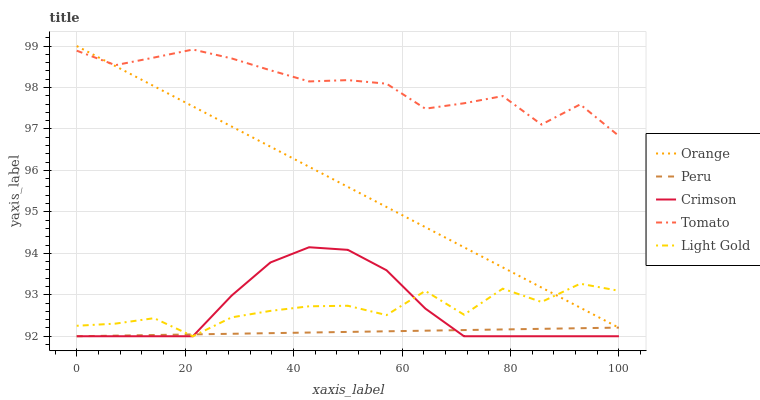Does Peru have the minimum area under the curve?
Answer yes or no. Yes. Does Tomato have the maximum area under the curve?
Answer yes or no. Yes. Does Crimson have the minimum area under the curve?
Answer yes or no. No. Does Crimson have the maximum area under the curve?
Answer yes or no. No. Is Peru the smoothest?
Answer yes or no. Yes. Is Light Gold the roughest?
Answer yes or no. Yes. Is Crimson the smoothest?
Answer yes or no. No. Is Crimson the roughest?
Answer yes or no. No. Does Tomato have the lowest value?
Answer yes or no. No. Does Orange have the highest value?
Answer yes or no. Yes. Does Crimson have the highest value?
Answer yes or no. No. Is Crimson less than Orange?
Answer yes or no. Yes. Is Tomato greater than Crimson?
Answer yes or no. Yes. Does Peru intersect Light Gold?
Answer yes or no. Yes. Is Peru less than Light Gold?
Answer yes or no. No. Is Peru greater than Light Gold?
Answer yes or no. No. Does Crimson intersect Orange?
Answer yes or no. No. 